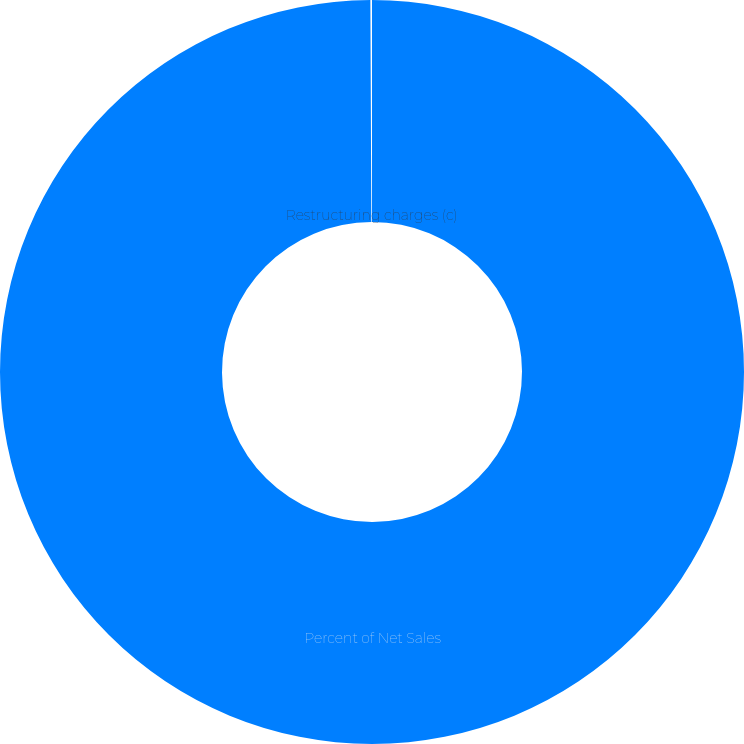<chart> <loc_0><loc_0><loc_500><loc_500><pie_chart><fcel>Percent of Net Sales<fcel>Restructuring charges (c)<nl><fcel>99.93%<fcel>0.07%<nl></chart> 